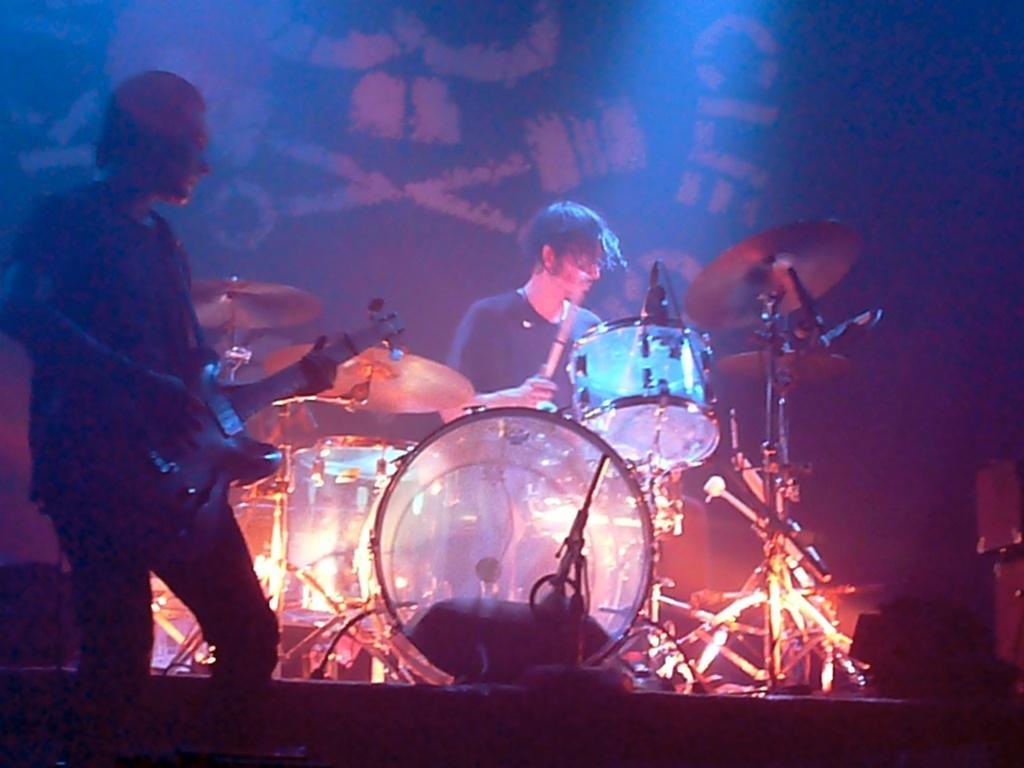Describe this image in one or two sentences. This looks like a musical concert. There are two persons in the middle. They are playing musical instruments. One is playing drums. Another one is playing guitar. There are lights in the middle. 